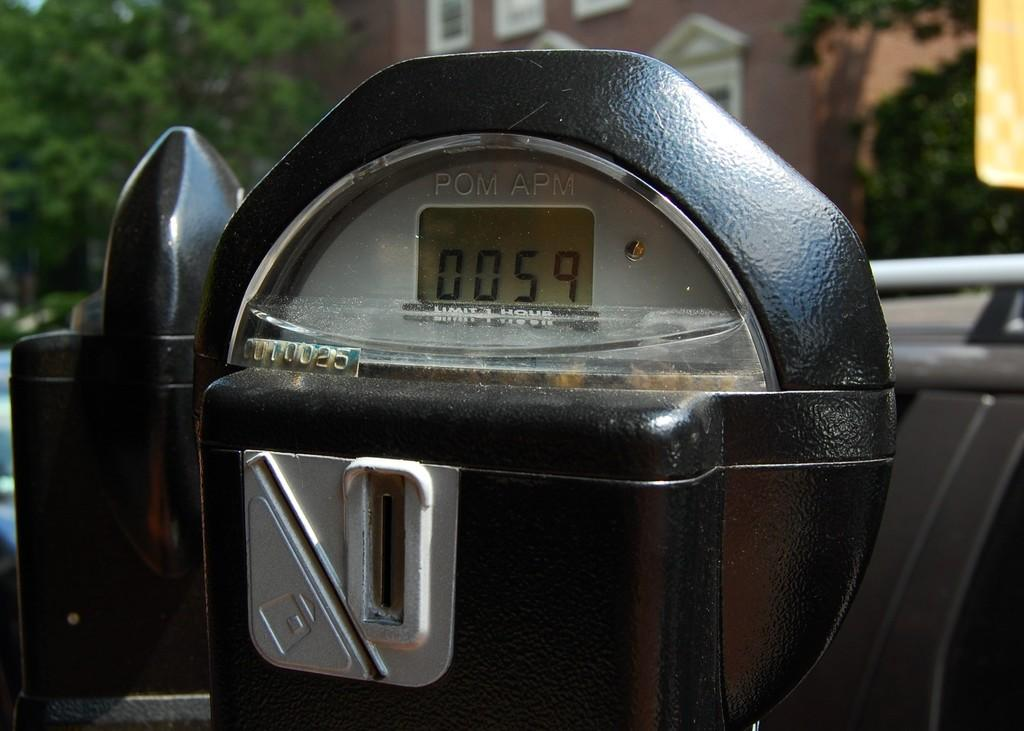<image>
Write a terse but informative summary of the picture. a black parking meter with fifty nine minutes left in it. 